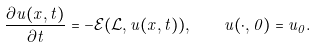<formula> <loc_0><loc_0><loc_500><loc_500>\frac { \partial u ( x , t ) } { \partial t } = - \mathcal { E } ( \mathcal { L } , u ( x , t ) ) , \quad u ( \cdot , 0 ) = u _ { 0 } .</formula> 